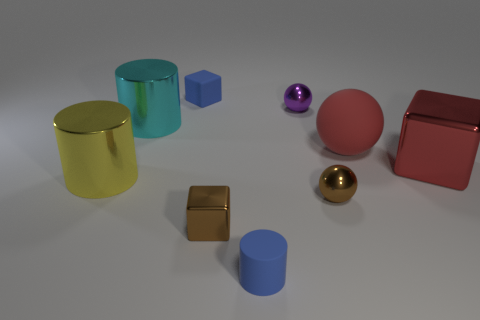What shape is the tiny shiny thing that is the same color as the small shiny cube?
Offer a very short reply. Sphere. There is a shiny cylinder that is right of the big yellow cylinder; how many big cyan cylinders are behind it?
Provide a short and direct response. 0. What number of yellow objects have the same material as the big cyan cylinder?
Make the answer very short. 1. There is a large yellow metallic cylinder; are there any red cubes left of it?
Provide a succinct answer. No. There is a matte cube that is the same size as the rubber cylinder; what is its color?
Your answer should be compact. Blue. What number of objects are big metallic objects that are left of the purple sphere or small purple metal objects?
Your answer should be compact. 3. There is a shiny object that is on the right side of the purple metallic object and in front of the big red block; how big is it?
Make the answer very short. Small. What size is the cube that is the same color as the large matte thing?
Keep it short and to the point. Large. What number of other things are the same size as the matte sphere?
Keep it short and to the point. 3. There is a big shiny cylinder in front of the big shiny object on the right side of the large metallic thing behind the red matte object; what color is it?
Make the answer very short. Yellow. 